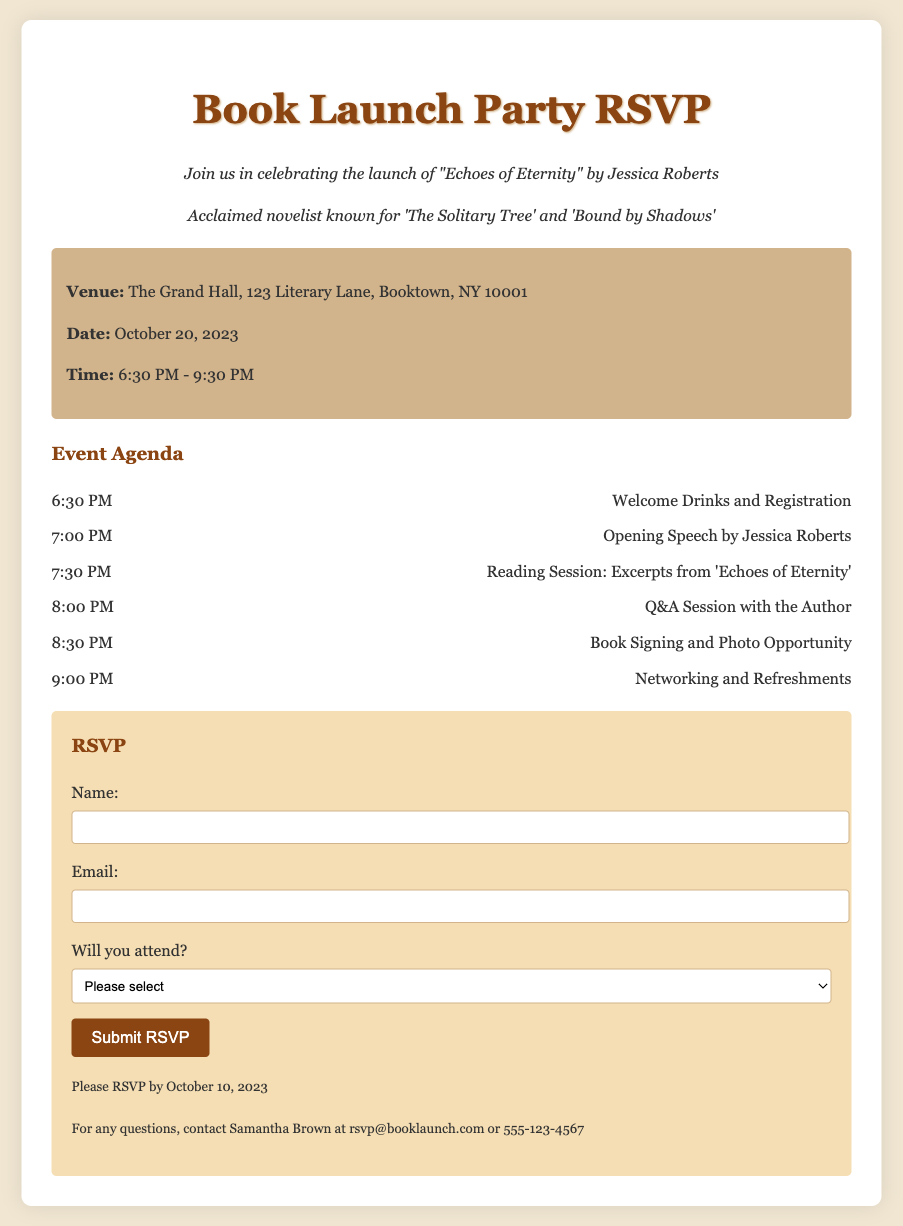What is the title of the book being launched? The title of the book is mentioned in the invitation as "Echoes of Eternity."
Answer: Echoes of Eternity Who is the author of the book? The author's name is provided in the document as Jessica Roberts.
Answer: Jessica Roberts What is the date of the book launch party? The date for the event is clearly outlined in the document as October 20, 2023.
Answer: October 20, 2023 What time does the book launch party start? The starting time for the event is indicated as 6:30 PM.
Answer: 6:30 PM What is the venue for the party? The document lists the venue as The Grand Hall, 123 Literary Lane, Booktown, NY 10001.
Answer: The Grand Hall, 123 Literary Lane, Booktown, NY 10001 What activity occurs right after the opening speech? The document describes that right after the opening speech by the author, there is a reading session for excerpts from the book.
Answer: Reading Session: Excerpts from 'Echoes of Eternity' By when should guests RSVP? The RSVP deadline is mentioned as October 10, 2023.
Answer: October 10, 2023 What is the first activity listed in the agenda? The first activity in the agenda is the "Welcome Drinks and Registration" which starts at 6:30 PM.
Answer: Welcome Drinks and Registration What contact information is provided for questions? The contact information given for inquiries is Samantha Brown's email and phone number.
Answer: rsvp@booklaunch.com or 555-123-4567 